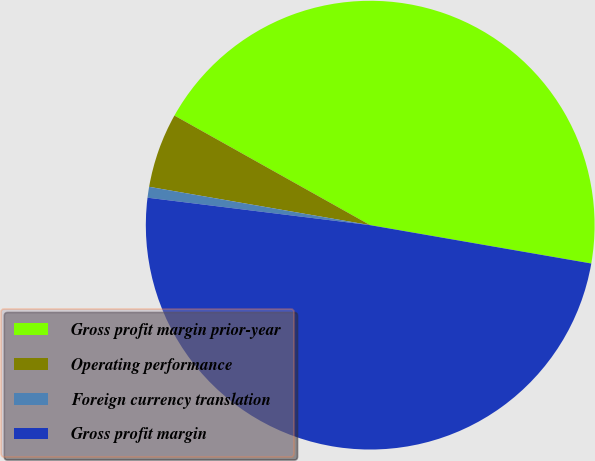Convert chart. <chart><loc_0><loc_0><loc_500><loc_500><pie_chart><fcel>Gross profit margin prior-year<fcel>Operating performance<fcel>Foreign currency translation<fcel>Gross profit margin<nl><fcel>44.61%<fcel>5.39%<fcel>0.78%<fcel>49.22%<nl></chart> 